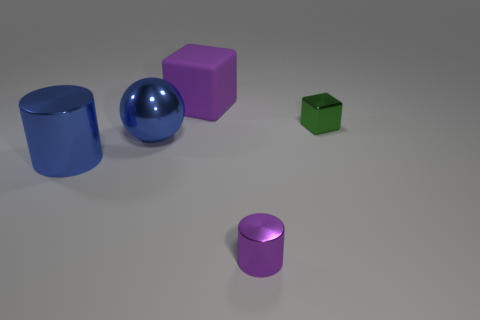Is the number of red metallic cylinders greater than the number of purple rubber things? no 